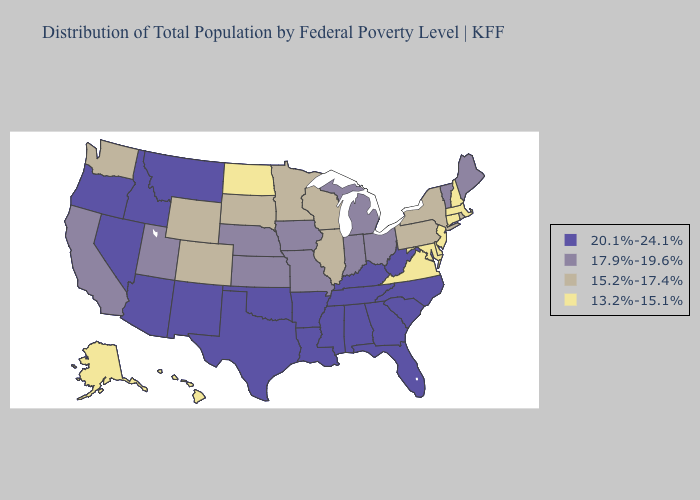What is the value of Illinois?
Short answer required. 15.2%-17.4%. Does Oregon have the highest value in the USA?
Answer briefly. Yes. What is the lowest value in the Northeast?
Quick response, please. 13.2%-15.1%. Does Florida have a higher value than South Carolina?
Short answer required. No. Does the first symbol in the legend represent the smallest category?
Answer briefly. No. What is the highest value in states that border Oregon?
Write a very short answer. 20.1%-24.1%. Does Wyoming have the lowest value in the USA?
Write a very short answer. No. What is the value of Indiana?
Give a very brief answer. 17.9%-19.6%. Name the states that have a value in the range 17.9%-19.6%?
Be succinct. California, Indiana, Iowa, Kansas, Maine, Michigan, Missouri, Nebraska, Ohio, Utah, Vermont. How many symbols are there in the legend?
Answer briefly. 4. Does Rhode Island have a higher value than Arizona?
Short answer required. No. What is the value of Kentucky?
Quick response, please. 20.1%-24.1%. How many symbols are there in the legend?
Give a very brief answer. 4. What is the value of Hawaii?
Concise answer only. 13.2%-15.1%. What is the value of North Carolina?
Be succinct. 20.1%-24.1%. 